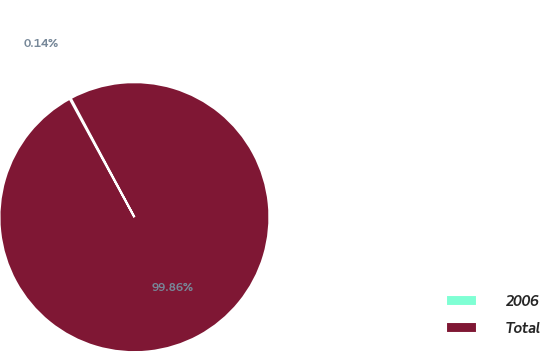<chart> <loc_0><loc_0><loc_500><loc_500><pie_chart><fcel>2006<fcel>Total<nl><fcel>0.14%<fcel>99.86%<nl></chart> 